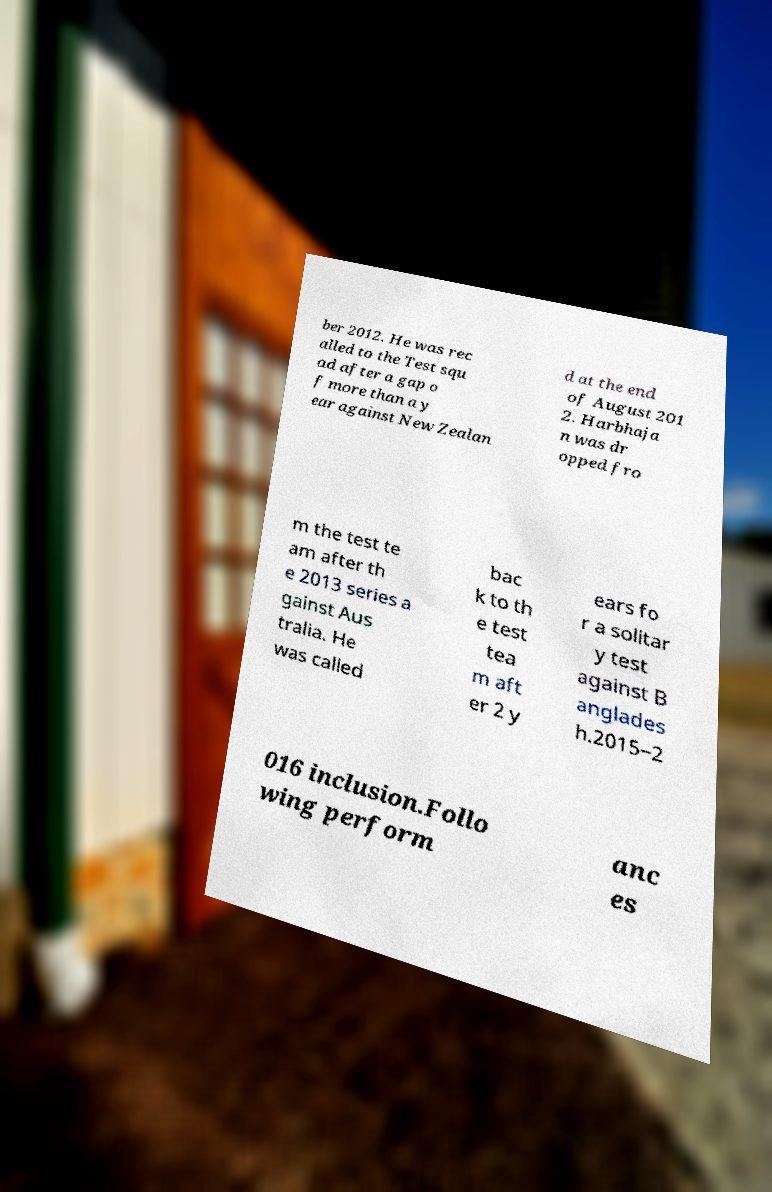Could you assist in decoding the text presented in this image and type it out clearly? ber 2012. He was rec alled to the Test squ ad after a gap o f more than a y ear against New Zealan d at the end of August 201 2. Harbhaja n was dr opped fro m the test te am after th e 2013 series a gainst Aus tralia. He was called bac k to th e test tea m aft er 2 y ears fo r a solitar y test against B anglades h.2015–2 016 inclusion.Follo wing perform anc es 